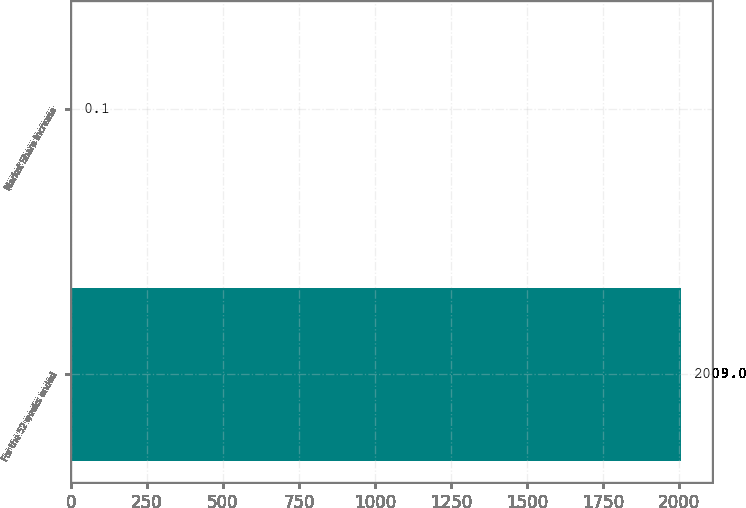<chart> <loc_0><loc_0><loc_500><loc_500><bar_chart><fcel>For the 52 weeks ended<fcel>Market Share Increase<nl><fcel>2009<fcel>0.1<nl></chart> 